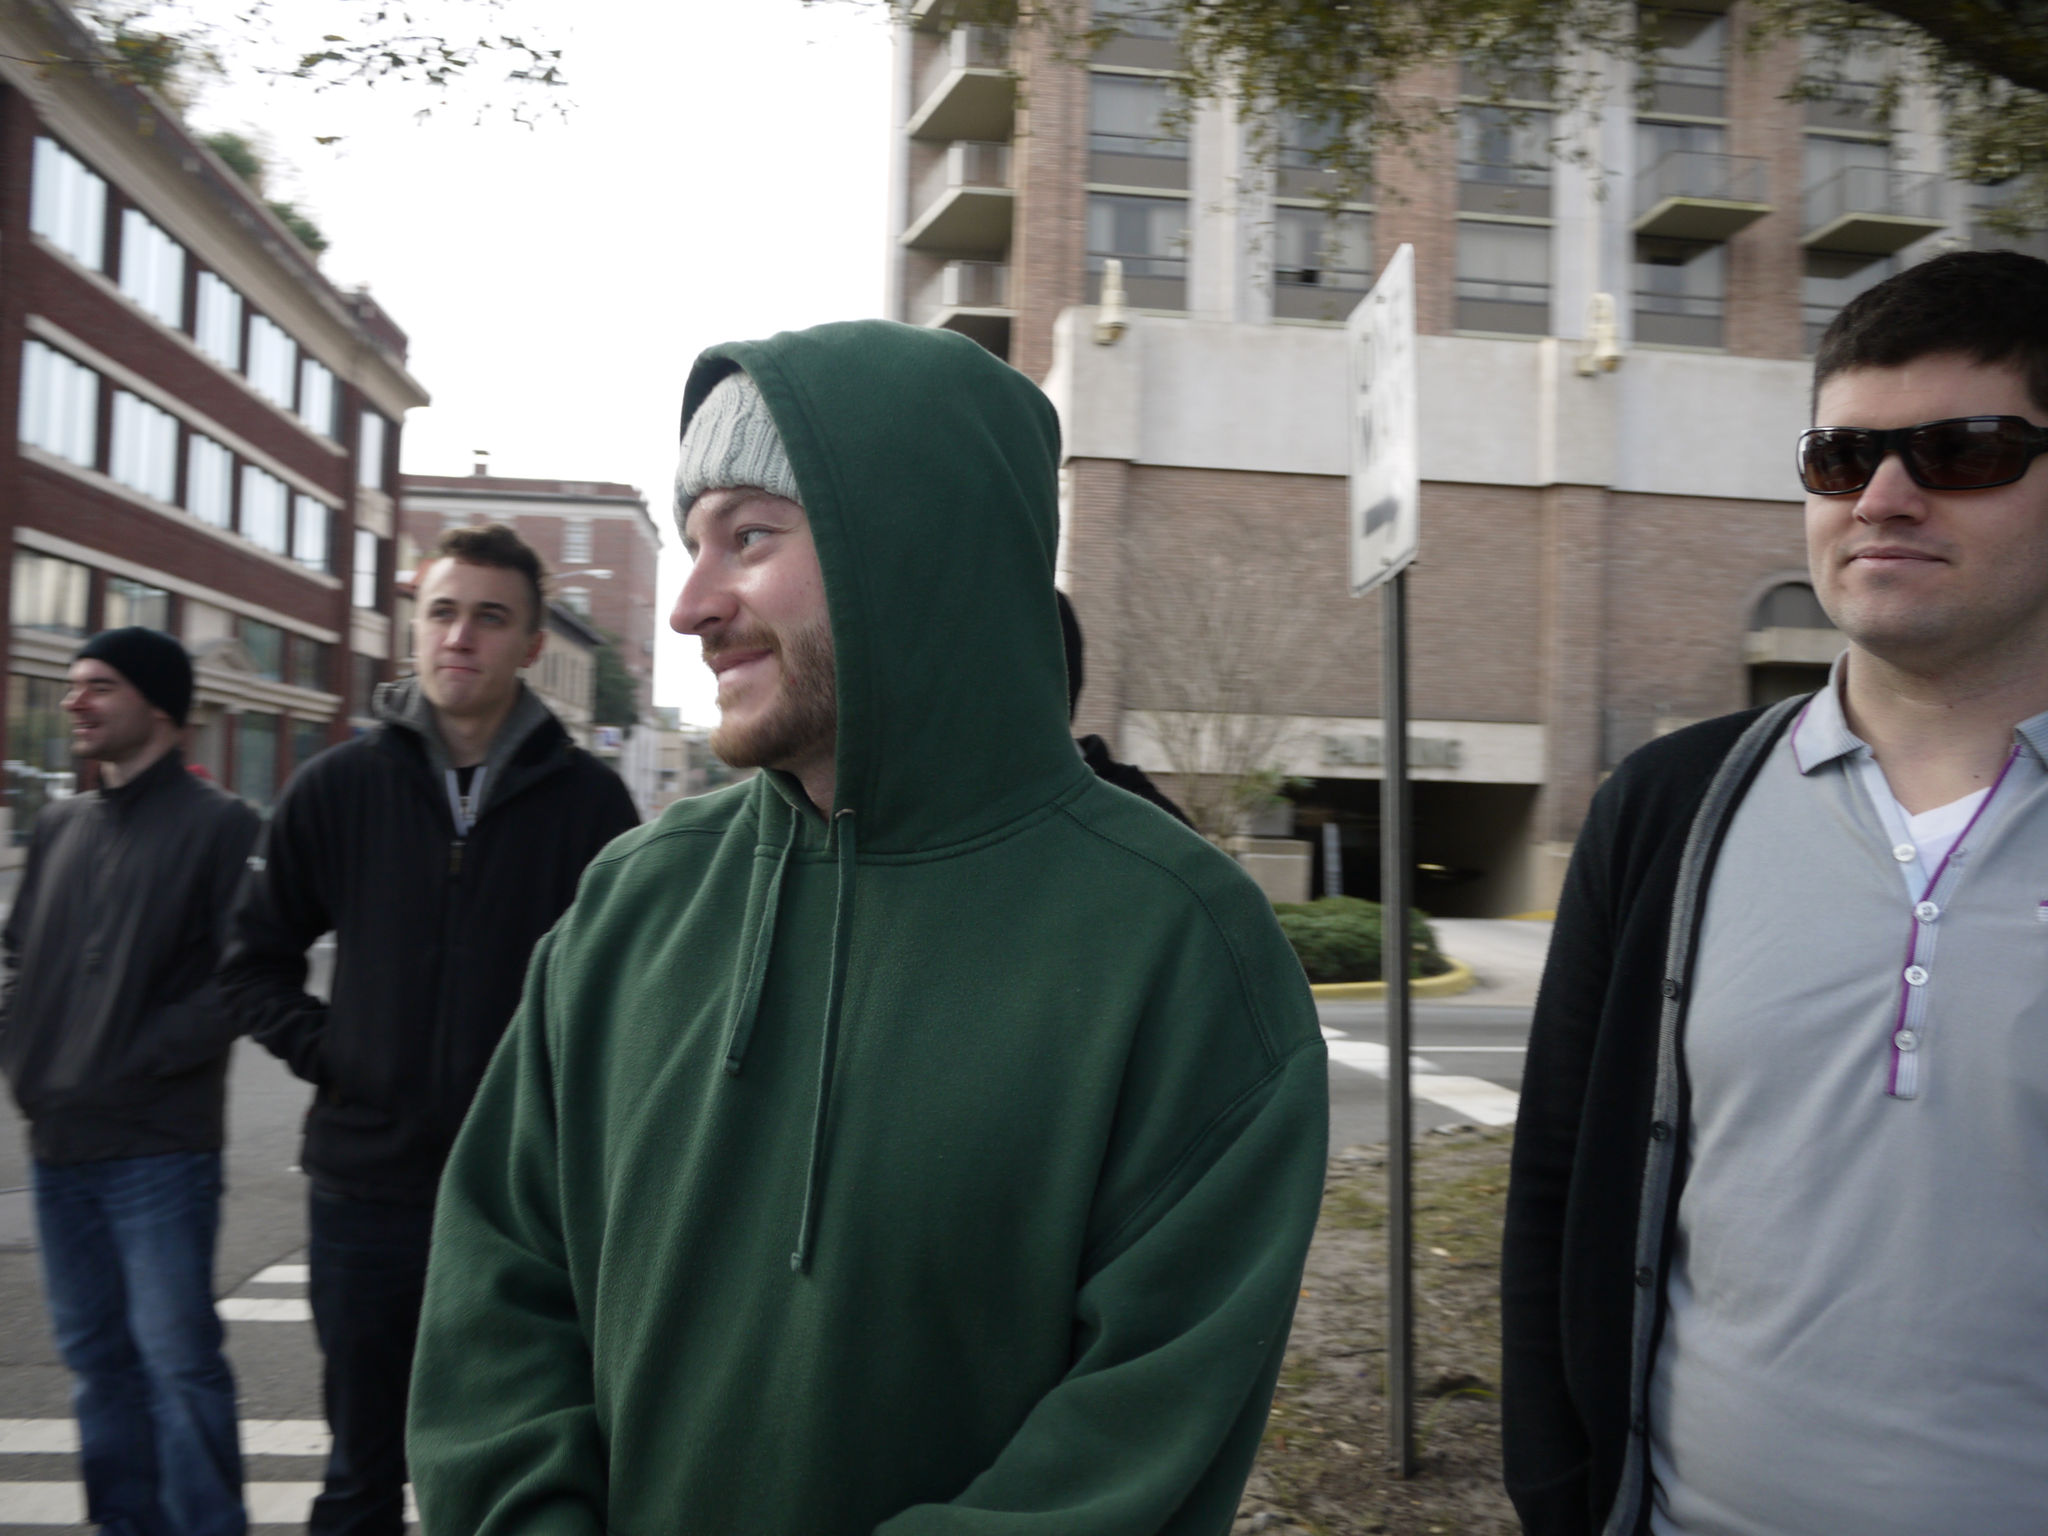Could you give a brief overview of what you see in this image? Here I can see four men are wearing jackets, standing on the road and everyone are smiling. At the back of these people there is a pole to which a board is attached and this pole is placed on the footpath. In the background there are some buildings. On the top of the image I can see the sky. 